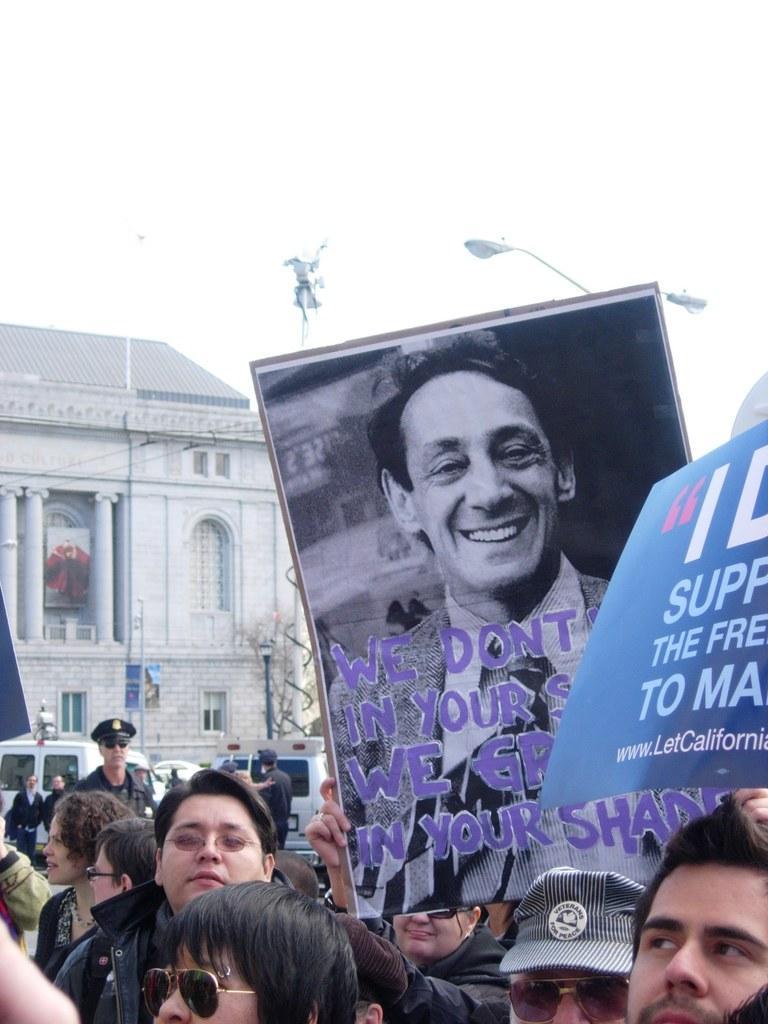How would you summarize this image in a sentence or two? There are some persons standing at the bottom of this image and some persons holding a posters as we can see on the right side of this image. There is a building on the left side of this image. There are some poles on the top of this poster. There is a sky in the background. 